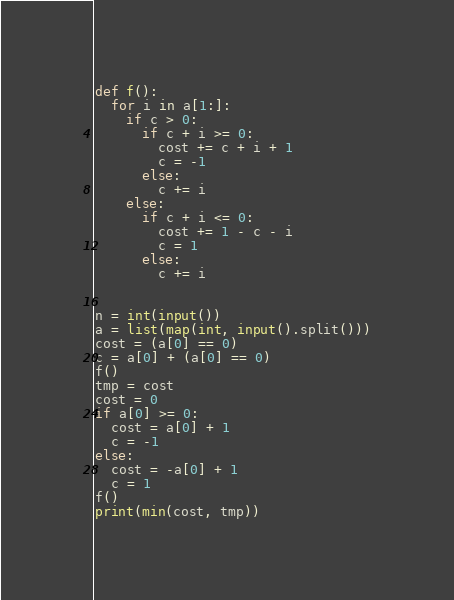Convert code to text. <code><loc_0><loc_0><loc_500><loc_500><_Python_>def f():
  for i in a[1:]:
    if c > 0:
      if c + i >= 0:
        cost += c + i + 1
        c = -1
      else:
        c += i
    else:
      if c + i <= 0:
        cost += 1 - c - i
        c = 1
      else:
        c += i


n = int(input())
a = list(map(int, input().split()))
cost = (a[0] == 0)
c = a[0] + (a[0] == 0)
f()
tmp = cost
cost = 0
if a[0] >= 0:
  cost = a[0] + 1
  c = -1
else:
  cost = -a[0] + 1
  c = 1
f()
print(min(cost, tmp))
</code> 